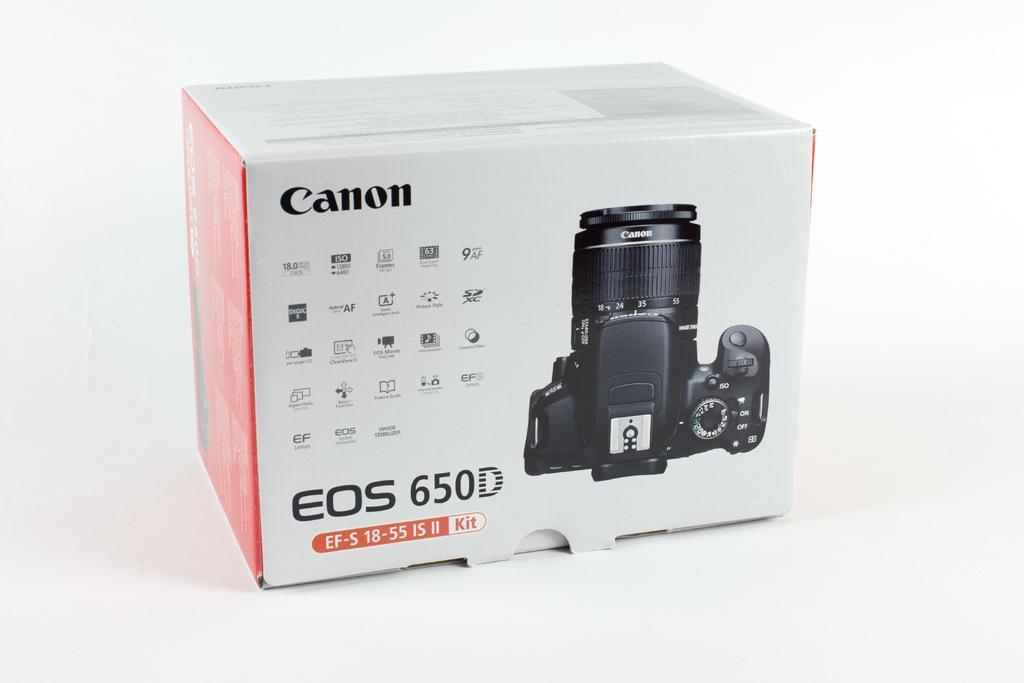Describe this image in one or two sentences. In this image there is a box. On the box there is a camera. There is text canon. There are small icons. On the left and right side of the box is in red color. There is a white background. 